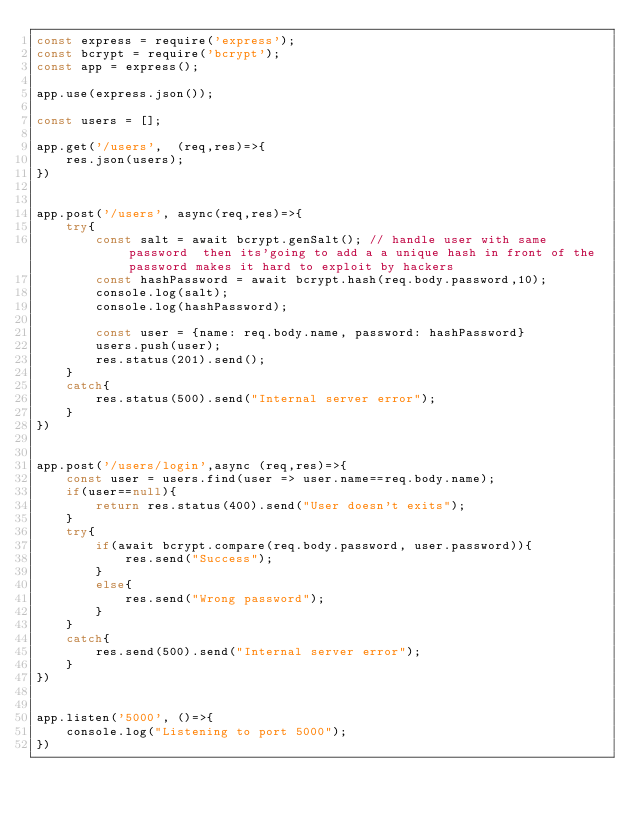Convert code to text. <code><loc_0><loc_0><loc_500><loc_500><_JavaScript_>const express = require('express');
const bcrypt = require('bcrypt');
const app = express();

app.use(express.json());

const users = [];

app.get('/users',  (req,res)=>{
    res.json(users);
})


app.post('/users', async(req,res)=>{
    try{
        const salt = await bcrypt.genSalt(); // handle user with same password  then its'going to add a a unique hash in front of the password makes it hard to exploit by hackers
        const hashPassword = await bcrypt.hash(req.body.password,10);
        console.log(salt);
        console.log(hashPassword);
        
        const user = {name: req.body.name, password: hashPassword}
        users.push(user);
        res.status(201).send();      
    }
    catch{
        res.status(500).send("Internal server error");
    }
})


app.post('/users/login',async (req,res)=>{
    const user = users.find(user => user.name==req.body.name);
    if(user==null){
        return res.status(400).send("User doesn't exits");
    }
    try{
        if(await bcrypt.compare(req.body.password, user.password)){
            res.send("Success");
        }
        else{
            res.send("Wrong password");
        }
    }
    catch{
        res.send(500).send("Internal server error");
    }
})


app.listen('5000', ()=>{
    console.log("Listening to port 5000");
})</code> 